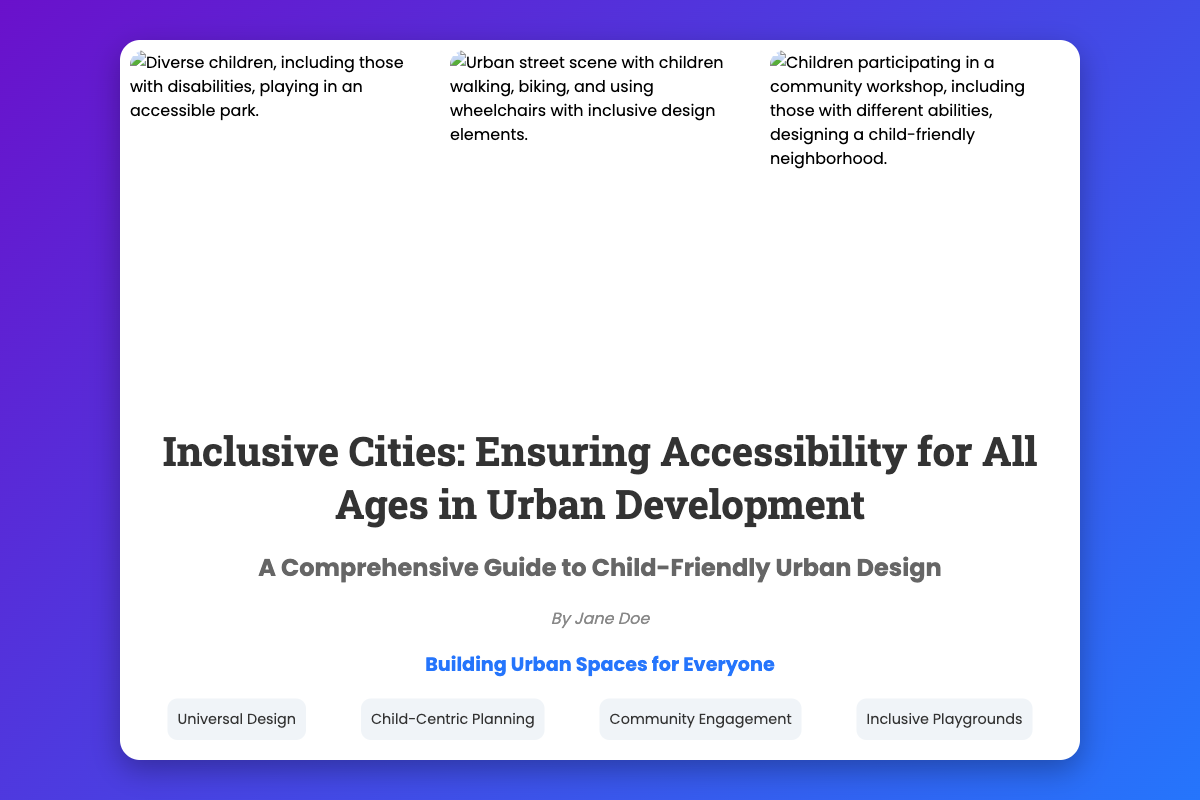What is the title of the book? The title can be found prominently displayed on the cover.
Answer: Inclusive Cities: Ensuring Accessibility for All Ages in Urban Development Who is the author of the book? The author's name is listed in the text content section.
Answer: Jane Doe What is the tagline of the book? The tagline is a concise phrase describing the book's theme.
Answer: Building Urban Spaces for Everyone How many key concepts are listed? The number of concepts can be counted in the key concepts section.
Answer: Four What kind of scenes are depicted in the images? The images highlight various aspects of children's interactions with urban spaces.
Answer: Diverse children engaging in urban activities What is the main focus of this book? The main focus is highlighted in the subtitle of the book.
Answer: Child-Friendly Urban Design What type of image is displayed on the left? The left image context relates to a specific setting involving children.
Answer: Accessible playground What does the second image depict? The second image showcases activities in an urban environment.
Answer: Urban street scene What is one of the concepts mentioned on the cover? Concepts related to urban design are explicitly listed on the cover.
Answer: Universal Design 